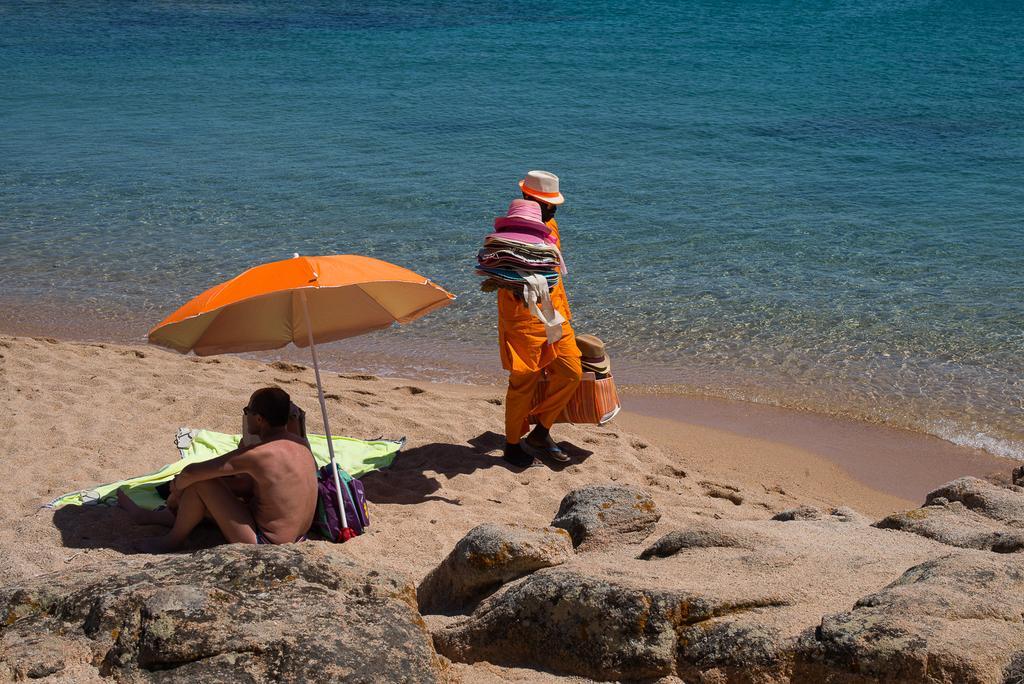Please provide a concise description of this image. In this image we can see a person sitting and there is an umbrella, bag and some other objects and we can see some rocks. There is a person walking and holding some hats and a bag with some objects and we can see the sea shore. 